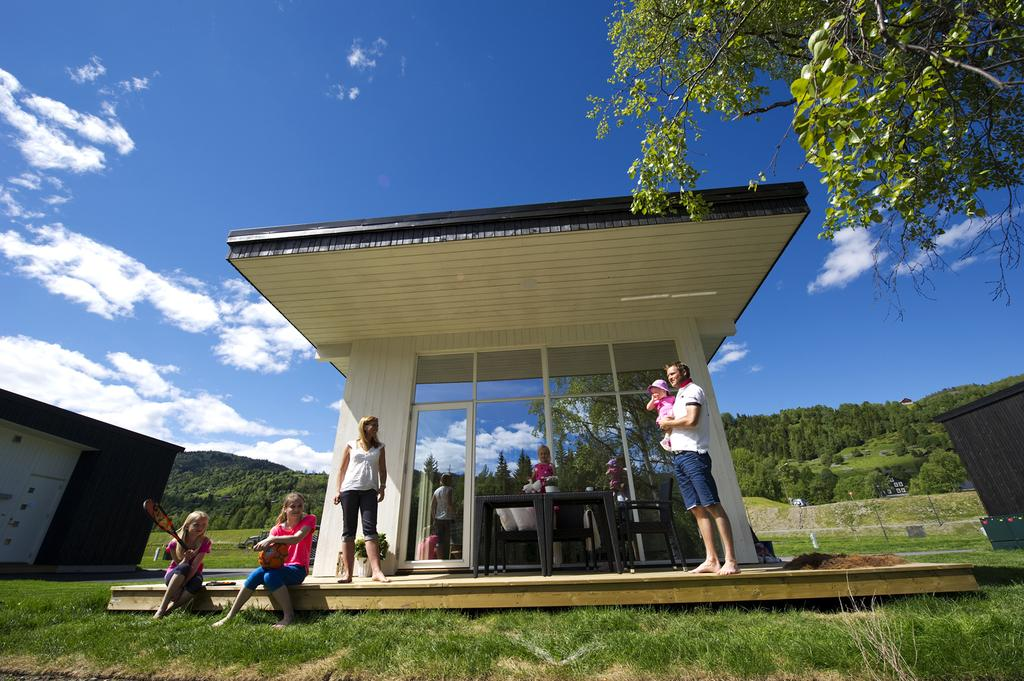How many people are in the foreground of the image? There are six persons in the foreground of the image. What type of ground surface is visible in the foreground? There is grass in the foreground of the image. What type of structure is present in the foreground? There is a shed in the foreground of the image. What can be seen in the background of the image? There are trees and mountains in the background of the image. What is the color of the sky in the image? The sky is blue, suggesting a sunny day. Can you tell me where the kitten is taking a bath in the image? There is no kitten or bath present in the image. What type of camping equipment can be seen in the image? There is no camping equipment visible in the image. 